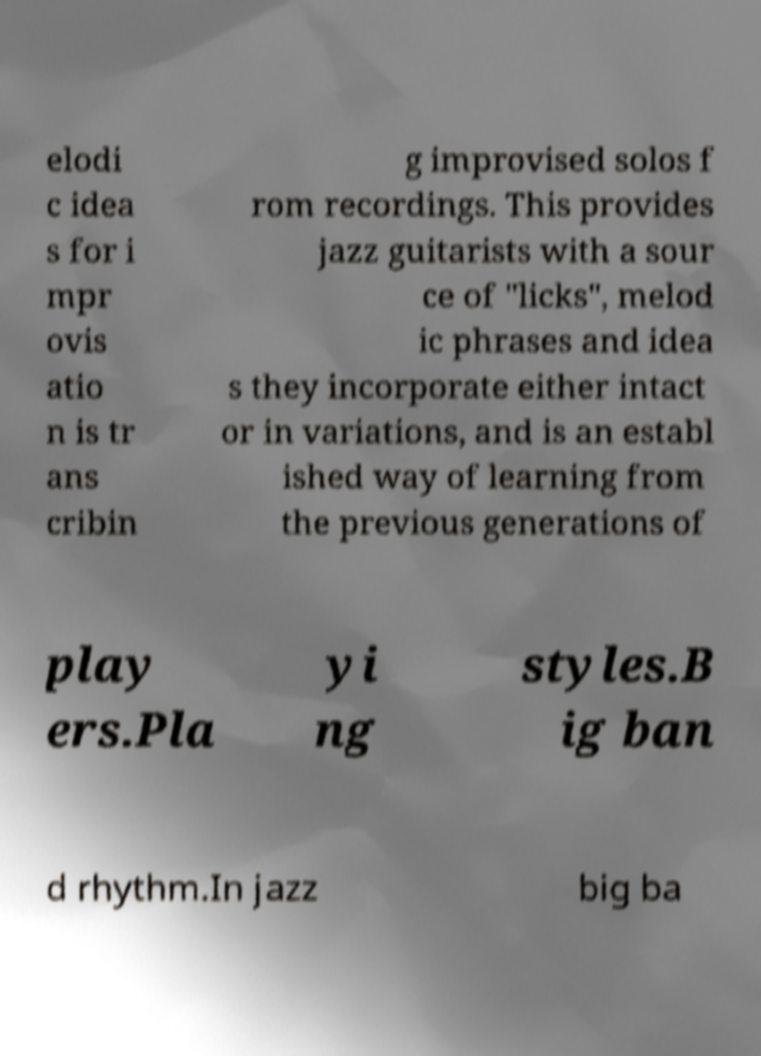Could you assist in decoding the text presented in this image and type it out clearly? elodi c idea s for i mpr ovis atio n is tr ans cribin g improvised solos f rom recordings. This provides jazz guitarists with a sour ce of "licks", melod ic phrases and idea s they incorporate either intact or in variations, and is an establ ished way of learning from the previous generations of play ers.Pla yi ng styles.B ig ban d rhythm.In jazz big ba 